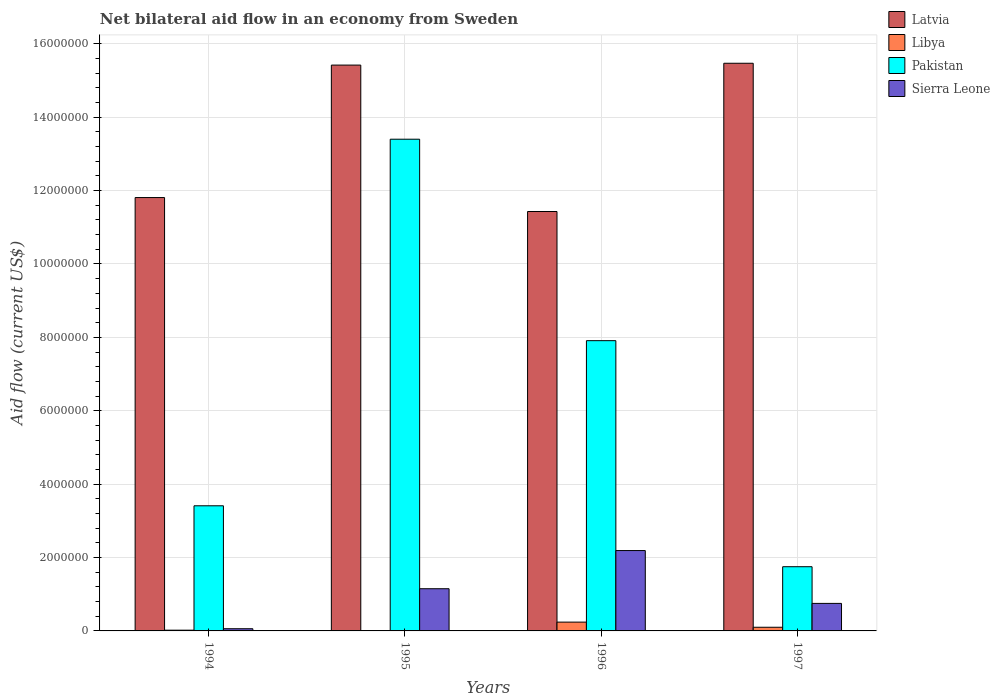How many groups of bars are there?
Provide a short and direct response. 4. Are the number of bars per tick equal to the number of legend labels?
Your answer should be very brief. Yes. How many bars are there on the 1st tick from the left?
Give a very brief answer. 4. What is the net bilateral aid flow in Pakistan in 1997?
Provide a short and direct response. 1.75e+06. Across all years, what is the maximum net bilateral aid flow in Libya?
Your response must be concise. 2.40e+05. Across all years, what is the minimum net bilateral aid flow in Latvia?
Ensure brevity in your answer.  1.14e+07. What is the difference between the net bilateral aid flow in Pakistan in 1995 and that in 1996?
Your response must be concise. 5.49e+06. What is the difference between the net bilateral aid flow in Libya in 1994 and the net bilateral aid flow in Pakistan in 1995?
Offer a terse response. -1.34e+07. What is the average net bilateral aid flow in Pakistan per year?
Offer a very short reply. 6.62e+06. In the year 1997, what is the difference between the net bilateral aid flow in Sierra Leone and net bilateral aid flow in Latvia?
Provide a succinct answer. -1.47e+07. What is the ratio of the net bilateral aid flow in Libya in 1995 to that in 1996?
Your response must be concise. 0.04. Is the net bilateral aid flow in Libya in 1994 less than that in 1996?
Keep it short and to the point. Yes. Is the difference between the net bilateral aid flow in Sierra Leone in 1995 and 1996 greater than the difference between the net bilateral aid flow in Latvia in 1995 and 1996?
Make the answer very short. No. What is the difference between the highest and the second highest net bilateral aid flow in Pakistan?
Make the answer very short. 5.49e+06. What is the difference between the highest and the lowest net bilateral aid flow in Sierra Leone?
Give a very brief answer. 2.13e+06. In how many years, is the net bilateral aid flow in Libya greater than the average net bilateral aid flow in Libya taken over all years?
Give a very brief answer. 2. Is it the case that in every year, the sum of the net bilateral aid flow in Sierra Leone and net bilateral aid flow in Libya is greater than the sum of net bilateral aid flow in Pakistan and net bilateral aid flow in Latvia?
Give a very brief answer. No. What does the 2nd bar from the left in 1996 represents?
Provide a succinct answer. Libya. What does the 1st bar from the right in 1996 represents?
Provide a succinct answer. Sierra Leone. How many bars are there?
Provide a succinct answer. 16. How many years are there in the graph?
Keep it short and to the point. 4. What is the difference between two consecutive major ticks on the Y-axis?
Provide a short and direct response. 2.00e+06. How many legend labels are there?
Your answer should be compact. 4. How are the legend labels stacked?
Ensure brevity in your answer.  Vertical. What is the title of the graph?
Your answer should be very brief. Net bilateral aid flow in an economy from Sweden. Does "Georgia" appear as one of the legend labels in the graph?
Provide a succinct answer. No. What is the label or title of the X-axis?
Your answer should be compact. Years. What is the Aid flow (current US$) of Latvia in 1994?
Your answer should be very brief. 1.18e+07. What is the Aid flow (current US$) of Libya in 1994?
Your response must be concise. 2.00e+04. What is the Aid flow (current US$) of Pakistan in 1994?
Your response must be concise. 3.41e+06. What is the Aid flow (current US$) of Sierra Leone in 1994?
Provide a succinct answer. 6.00e+04. What is the Aid flow (current US$) in Latvia in 1995?
Give a very brief answer. 1.54e+07. What is the Aid flow (current US$) of Pakistan in 1995?
Offer a very short reply. 1.34e+07. What is the Aid flow (current US$) of Sierra Leone in 1995?
Offer a terse response. 1.15e+06. What is the Aid flow (current US$) of Latvia in 1996?
Give a very brief answer. 1.14e+07. What is the Aid flow (current US$) of Libya in 1996?
Provide a short and direct response. 2.40e+05. What is the Aid flow (current US$) of Pakistan in 1996?
Give a very brief answer. 7.91e+06. What is the Aid flow (current US$) in Sierra Leone in 1996?
Keep it short and to the point. 2.19e+06. What is the Aid flow (current US$) of Latvia in 1997?
Provide a short and direct response. 1.55e+07. What is the Aid flow (current US$) of Pakistan in 1997?
Give a very brief answer. 1.75e+06. What is the Aid flow (current US$) in Sierra Leone in 1997?
Keep it short and to the point. 7.50e+05. Across all years, what is the maximum Aid flow (current US$) in Latvia?
Provide a succinct answer. 1.55e+07. Across all years, what is the maximum Aid flow (current US$) of Pakistan?
Ensure brevity in your answer.  1.34e+07. Across all years, what is the maximum Aid flow (current US$) of Sierra Leone?
Provide a short and direct response. 2.19e+06. Across all years, what is the minimum Aid flow (current US$) of Latvia?
Provide a succinct answer. 1.14e+07. Across all years, what is the minimum Aid flow (current US$) of Libya?
Offer a terse response. 10000. Across all years, what is the minimum Aid flow (current US$) of Pakistan?
Keep it short and to the point. 1.75e+06. Across all years, what is the minimum Aid flow (current US$) in Sierra Leone?
Provide a short and direct response. 6.00e+04. What is the total Aid flow (current US$) of Latvia in the graph?
Give a very brief answer. 5.41e+07. What is the total Aid flow (current US$) in Pakistan in the graph?
Offer a terse response. 2.65e+07. What is the total Aid flow (current US$) of Sierra Leone in the graph?
Provide a succinct answer. 4.15e+06. What is the difference between the Aid flow (current US$) in Latvia in 1994 and that in 1995?
Your response must be concise. -3.61e+06. What is the difference between the Aid flow (current US$) of Libya in 1994 and that in 1995?
Ensure brevity in your answer.  10000. What is the difference between the Aid flow (current US$) in Pakistan in 1994 and that in 1995?
Your answer should be compact. -9.99e+06. What is the difference between the Aid flow (current US$) of Sierra Leone in 1994 and that in 1995?
Make the answer very short. -1.09e+06. What is the difference between the Aid flow (current US$) of Libya in 1994 and that in 1996?
Keep it short and to the point. -2.20e+05. What is the difference between the Aid flow (current US$) of Pakistan in 1994 and that in 1996?
Provide a short and direct response. -4.50e+06. What is the difference between the Aid flow (current US$) of Sierra Leone in 1994 and that in 1996?
Provide a short and direct response. -2.13e+06. What is the difference between the Aid flow (current US$) of Latvia in 1994 and that in 1997?
Provide a short and direct response. -3.66e+06. What is the difference between the Aid flow (current US$) in Pakistan in 1994 and that in 1997?
Offer a very short reply. 1.66e+06. What is the difference between the Aid flow (current US$) in Sierra Leone in 1994 and that in 1997?
Your response must be concise. -6.90e+05. What is the difference between the Aid flow (current US$) of Latvia in 1995 and that in 1996?
Your answer should be very brief. 3.99e+06. What is the difference between the Aid flow (current US$) of Libya in 1995 and that in 1996?
Ensure brevity in your answer.  -2.30e+05. What is the difference between the Aid flow (current US$) of Pakistan in 1995 and that in 1996?
Ensure brevity in your answer.  5.49e+06. What is the difference between the Aid flow (current US$) of Sierra Leone in 1995 and that in 1996?
Make the answer very short. -1.04e+06. What is the difference between the Aid flow (current US$) of Pakistan in 1995 and that in 1997?
Ensure brevity in your answer.  1.16e+07. What is the difference between the Aid flow (current US$) of Sierra Leone in 1995 and that in 1997?
Give a very brief answer. 4.00e+05. What is the difference between the Aid flow (current US$) in Latvia in 1996 and that in 1997?
Offer a very short reply. -4.04e+06. What is the difference between the Aid flow (current US$) of Pakistan in 1996 and that in 1997?
Give a very brief answer. 6.16e+06. What is the difference between the Aid flow (current US$) in Sierra Leone in 1996 and that in 1997?
Give a very brief answer. 1.44e+06. What is the difference between the Aid flow (current US$) in Latvia in 1994 and the Aid flow (current US$) in Libya in 1995?
Offer a very short reply. 1.18e+07. What is the difference between the Aid flow (current US$) in Latvia in 1994 and the Aid flow (current US$) in Pakistan in 1995?
Keep it short and to the point. -1.59e+06. What is the difference between the Aid flow (current US$) of Latvia in 1994 and the Aid flow (current US$) of Sierra Leone in 1995?
Give a very brief answer. 1.07e+07. What is the difference between the Aid flow (current US$) in Libya in 1994 and the Aid flow (current US$) in Pakistan in 1995?
Offer a terse response. -1.34e+07. What is the difference between the Aid flow (current US$) in Libya in 1994 and the Aid flow (current US$) in Sierra Leone in 1995?
Your answer should be very brief. -1.13e+06. What is the difference between the Aid flow (current US$) in Pakistan in 1994 and the Aid flow (current US$) in Sierra Leone in 1995?
Offer a very short reply. 2.26e+06. What is the difference between the Aid flow (current US$) in Latvia in 1994 and the Aid flow (current US$) in Libya in 1996?
Your answer should be compact. 1.16e+07. What is the difference between the Aid flow (current US$) in Latvia in 1994 and the Aid flow (current US$) in Pakistan in 1996?
Your response must be concise. 3.90e+06. What is the difference between the Aid flow (current US$) of Latvia in 1994 and the Aid flow (current US$) of Sierra Leone in 1996?
Keep it short and to the point. 9.62e+06. What is the difference between the Aid flow (current US$) in Libya in 1994 and the Aid flow (current US$) in Pakistan in 1996?
Your answer should be very brief. -7.89e+06. What is the difference between the Aid flow (current US$) in Libya in 1994 and the Aid flow (current US$) in Sierra Leone in 1996?
Make the answer very short. -2.17e+06. What is the difference between the Aid flow (current US$) of Pakistan in 1994 and the Aid flow (current US$) of Sierra Leone in 1996?
Ensure brevity in your answer.  1.22e+06. What is the difference between the Aid flow (current US$) in Latvia in 1994 and the Aid flow (current US$) in Libya in 1997?
Make the answer very short. 1.17e+07. What is the difference between the Aid flow (current US$) of Latvia in 1994 and the Aid flow (current US$) of Pakistan in 1997?
Provide a short and direct response. 1.01e+07. What is the difference between the Aid flow (current US$) in Latvia in 1994 and the Aid flow (current US$) in Sierra Leone in 1997?
Offer a terse response. 1.11e+07. What is the difference between the Aid flow (current US$) in Libya in 1994 and the Aid flow (current US$) in Pakistan in 1997?
Your answer should be very brief. -1.73e+06. What is the difference between the Aid flow (current US$) of Libya in 1994 and the Aid flow (current US$) of Sierra Leone in 1997?
Give a very brief answer. -7.30e+05. What is the difference between the Aid flow (current US$) of Pakistan in 1994 and the Aid flow (current US$) of Sierra Leone in 1997?
Make the answer very short. 2.66e+06. What is the difference between the Aid flow (current US$) in Latvia in 1995 and the Aid flow (current US$) in Libya in 1996?
Ensure brevity in your answer.  1.52e+07. What is the difference between the Aid flow (current US$) of Latvia in 1995 and the Aid flow (current US$) of Pakistan in 1996?
Your response must be concise. 7.51e+06. What is the difference between the Aid flow (current US$) in Latvia in 1995 and the Aid flow (current US$) in Sierra Leone in 1996?
Your answer should be very brief. 1.32e+07. What is the difference between the Aid flow (current US$) in Libya in 1995 and the Aid flow (current US$) in Pakistan in 1996?
Provide a succinct answer. -7.90e+06. What is the difference between the Aid flow (current US$) of Libya in 1995 and the Aid flow (current US$) of Sierra Leone in 1996?
Your response must be concise. -2.18e+06. What is the difference between the Aid flow (current US$) of Pakistan in 1995 and the Aid flow (current US$) of Sierra Leone in 1996?
Your answer should be very brief. 1.12e+07. What is the difference between the Aid flow (current US$) of Latvia in 1995 and the Aid flow (current US$) of Libya in 1997?
Keep it short and to the point. 1.53e+07. What is the difference between the Aid flow (current US$) in Latvia in 1995 and the Aid flow (current US$) in Pakistan in 1997?
Provide a succinct answer. 1.37e+07. What is the difference between the Aid flow (current US$) of Latvia in 1995 and the Aid flow (current US$) of Sierra Leone in 1997?
Ensure brevity in your answer.  1.47e+07. What is the difference between the Aid flow (current US$) of Libya in 1995 and the Aid flow (current US$) of Pakistan in 1997?
Offer a terse response. -1.74e+06. What is the difference between the Aid flow (current US$) of Libya in 1995 and the Aid flow (current US$) of Sierra Leone in 1997?
Give a very brief answer. -7.40e+05. What is the difference between the Aid flow (current US$) in Pakistan in 1995 and the Aid flow (current US$) in Sierra Leone in 1997?
Ensure brevity in your answer.  1.26e+07. What is the difference between the Aid flow (current US$) in Latvia in 1996 and the Aid flow (current US$) in Libya in 1997?
Your response must be concise. 1.13e+07. What is the difference between the Aid flow (current US$) of Latvia in 1996 and the Aid flow (current US$) of Pakistan in 1997?
Your answer should be compact. 9.68e+06. What is the difference between the Aid flow (current US$) in Latvia in 1996 and the Aid flow (current US$) in Sierra Leone in 1997?
Ensure brevity in your answer.  1.07e+07. What is the difference between the Aid flow (current US$) in Libya in 1996 and the Aid flow (current US$) in Pakistan in 1997?
Give a very brief answer. -1.51e+06. What is the difference between the Aid flow (current US$) of Libya in 1996 and the Aid flow (current US$) of Sierra Leone in 1997?
Make the answer very short. -5.10e+05. What is the difference between the Aid flow (current US$) in Pakistan in 1996 and the Aid flow (current US$) in Sierra Leone in 1997?
Keep it short and to the point. 7.16e+06. What is the average Aid flow (current US$) in Latvia per year?
Provide a succinct answer. 1.35e+07. What is the average Aid flow (current US$) in Libya per year?
Give a very brief answer. 9.25e+04. What is the average Aid flow (current US$) in Pakistan per year?
Provide a succinct answer. 6.62e+06. What is the average Aid flow (current US$) in Sierra Leone per year?
Your response must be concise. 1.04e+06. In the year 1994, what is the difference between the Aid flow (current US$) of Latvia and Aid flow (current US$) of Libya?
Ensure brevity in your answer.  1.18e+07. In the year 1994, what is the difference between the Aid flow (current US$) in Latvia and Aid flow (current US$) in Pakistan?
Give a very brief answer. 8.40e+06. In the year 1994, what is the difference between the Aid flow (current US$) in Latvia and Aid flow (current US$) in Sierra Leone?
Provide a short and direct response. 1.18e+07. In the year 1994, what is the difference between the Aid flow (current US$) of Libya and Aid flow (current US$) of Pakistan?
Your answer should be compact. -3.39e+06. In the year 1994, what is the difference between the Aid flow (current US$) in Pakistan and Aid flow (current US$) in Sierra Leone?
Offer a very short reply. 3.35e+06. In the year 1995, what is the difference between the Aid flow (current US$) of Latvia and Aid flow (current US$) of Libya?
Give a very brief answer. 1.54e+07. In the year 1995, what is the difference between the Aid flow (current US$) in Latvia and Aid flow (current US$) in Pakistan?
Your response must be concise. 2.02e+06. In the year 1995, what is the difference between the Aid flow (current US$) in Latvia and Aid flow (current US$) in Sierra Leone?
Your answer should be very brief. 1.43e+07. In the year 1995, what is the difference between the Aid flow (current US$) of Libya and Aid flow (current US$) of Pakistan?
Ensure brevity in your answer.  -1.34e+07. In the year 1995, what is the difference between the Aid flow (current US$) in Libya and Aid flow (current US$) in Sierra Leone?
Make the answer very short. -1.14e+06. In the year 1995, what is the difference between the Aid flow (current US$) of Pakistan and Aid flow (current US$) of Sierra Leone?
Your response must be concise. 1.22e+07. In the year 1996, what is the difference between the Aid flow (current US$) of Latvia and Aid flow (current US$) of Libya?
Your answer should be compact. 1.12e+07. In the year 1996, what is the difference between the Aid flow (current US$) in Latvia and Aid flow (current US$) in Pakistan?
Provide a short and direct response. 3.52e+06. In the year 1996, what is the difference between the Aid flow (current US$) of Latvia and Aid flow (current US$) of Sierra Leone?
Provide a short and direct response. 9.24e+06. In the year 1996, what is the difference between the Aid flow (current US$) of Libya and Aid flow (current US$) of Pakistan?
Give a very brief answer. -7.67e+06. In the year 1996, what is the difference between the Aid flow (current US$) in Libya and Aid flow (current US$) in Sierra Leone?
Provide a short and direct response. -1.95e+06. In the year 1996, what is the difference between the Aid flow (current US$) of Pakistan and Aid flow (current US$) of Sierra Leone?
Your answer should be very brief. 5.72e+06. In the year 1997, what is the difference between the Aid flow (current US$) of Latvia and Aid flow (current US$) of Libya?
Provide a short and direct response. 1.54e+07. In the year 1997, what is the difference between the Aid flow (current US$) of Latvia and Aid flow (current US$) of Pakistan?
Ensure brevity in your answer.  1.37e+07. In the year 1997, what is the difference between the Aid flow (current US$) of Latvia and Aid flow (current US$) of Sierra Leone?
Your response must be concise. 1.47e+07. In the year 1997, what is the difference between the Aid flow (current US$) in Libya and Aid flow (current US$) in Pakistan?
Make the answer very short. -1.65e+06. In the year 1997, what is the difference between the Aid flow (current US$) of Libya and Aid flow (current US$) of Sierra Leone?
Ensure brevity in your answer.  -6.50e+05. What is the ratio of the Aid flow (current US$) in Latvia in 1994 to that in 1995?
Offer a very short reply. 0.77. What is the ratio of the Aid flow (current US$) of Pakistan in 1994 to that in 1995?
Offer a terse response. 0.25. What is the ratio of the Aid flow (current US$) in Sierra Leone in 1994 to that in 1995?
Ensure brevity in your answer.  0.05. What is the ratio of the Aid flow (current US$) of Latvia in 1994 to that in 1996?
Give a very brief answer. 1.03. What is the ratio of the Aid flow (current US$) of Libya in 1994 to that in 1996?
Make the answer very short. 0.08. What is the ratio of the Aid flow (current US$) of Pakistan in 1994 to that in 1996?
Provide a succinct answer. 0.43. What is the ratio of the Aid flow (current US$) of Sierra Leone in 1994 to that in 1996?
Provide a short and direct response. 0.03. What is the ratio of the Aid flow (current US$) of Latvia in 1994 to that in 1997?
Your answer should be compact. 0.76. What is the ratio of the Aid flow (current US$) in Pakistan in 1994 to that in 1997?
Your answer should be compact. 1.95. What is the ratio of the Aid flow (current US$) in Sierra Leone in 1994 to that in 1997?
Provide a succinct answer. 0.08. What is the ratio of the Aid flow (current US$) of Latvia in 1995 to that in 1996?
Offer a very short reply. 1.35. What is the ratio of the Aid flow (current US$) in Libya in 1995 to that in 1996?
Give a very brief answer. 0.04. What is the ratio of the Aid flow (current US$) of Pakistan in 1995 to that in 1996?
Your answer should be compact. 1.69. What is the ratio of the Aid flow (current US$) in Sierra Leone in 1995 to that in 1996?
Your answer should be very brief. 0.53. What is the ratio of the Aid flow (current US$) of Libya in 1995 to that in 1997?
Your answer should be very brief. 0.1. What is the ratio of the Aid flow (current US$) in Pakistan in 1995 to that in 1997?
Offer a very short reply. 7.66. What is the ratio of the Aid flow (current US$) of Sierra Leone in 1995 to that in 1997?
Ensure brevity in your answer.  1.53. What is the ratio of the Aid flow (current US$) in Latvia in 1996 to that in 1997?
Ensure brevity in your answer.  0.74. What is the ratio of the Aid flow (current US$) in Pakistan in 1996 to that in 1997?
Give a very brief answer. 4.52. What is the ratio of the Aid flow (current US$) in Sierra Leone in 1996 to that in 1997?
Make the answer very short. 2.92. What is the difference between the highest and the second highest Aid flow (current US$) of Libya?
Make the answer very short. 1.40e+05. What is the difference between the highest and the second highest Aid flow (current US$) of Pakistan?
Your answer should be compact. 5.49e+06. What is the difference between the highest and the second highest Aid flow (current US$) of Sierra Leone?
Your response must be concise. 1.04e+06. What is the difference between the highest and the lowest Aid flow (current US$) of Latvia?
Make the answer very short. 4.04e+06. What is the difference between the highest and the lowest Aid flow (current US$) in Pakistan?
Your answer should be compact. 1.16e+07. What is the difference between the highest and the lowest Aid flow (current US$) in Sierra Leone?
Your answer should be compact. 2.13e+06. 